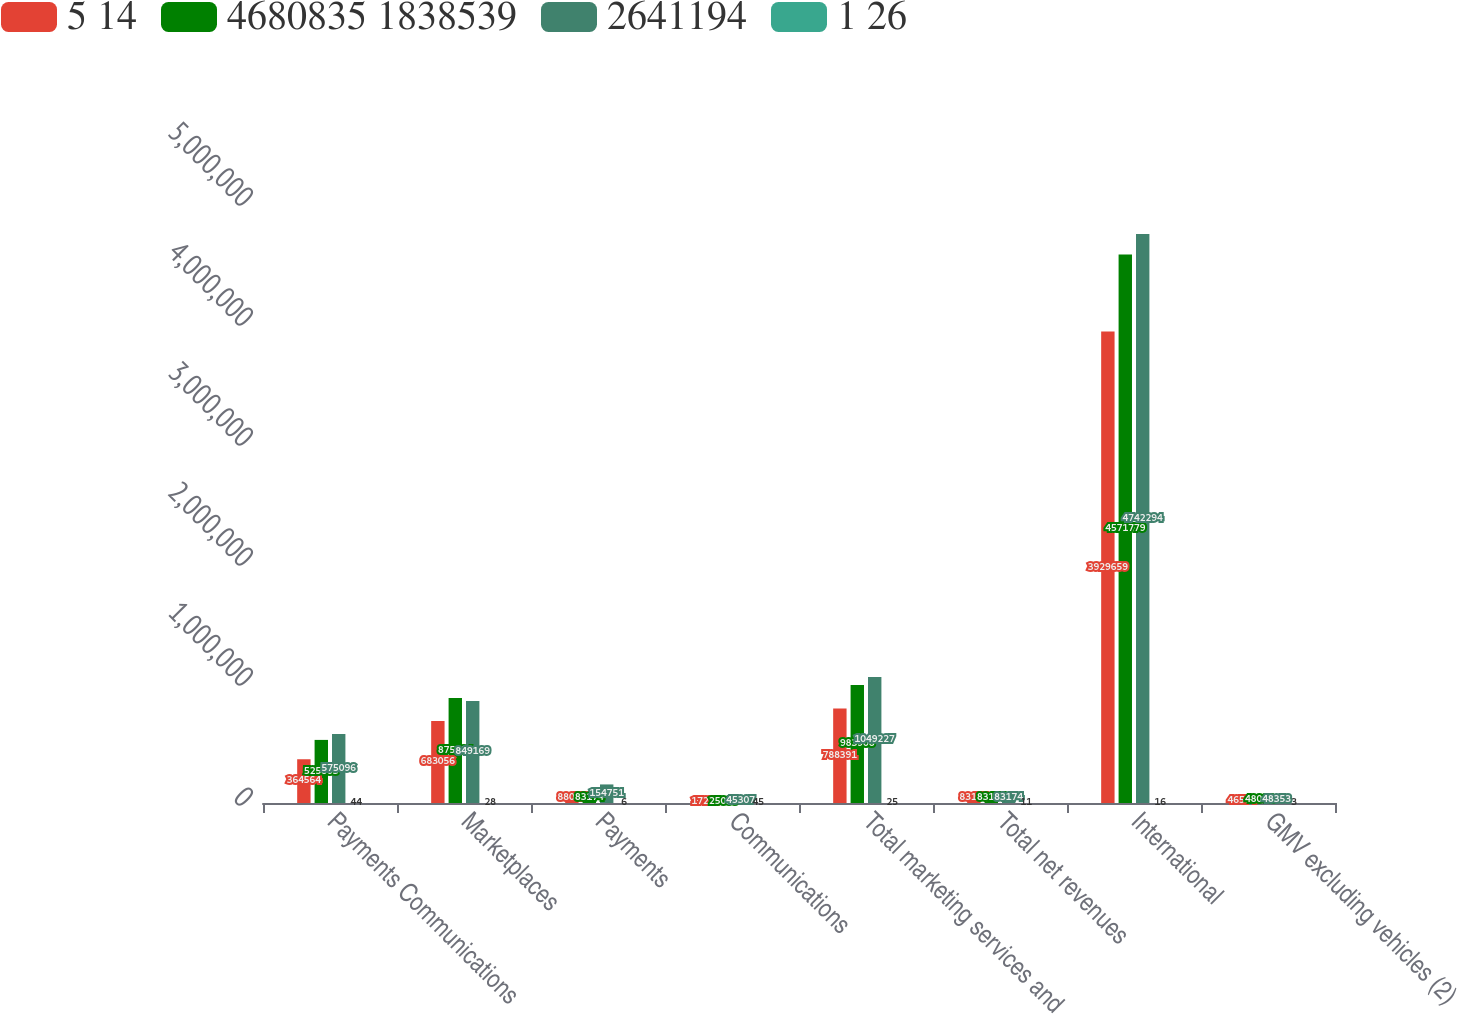Convert chart to OTSL. <chart><loc_0><loc_0><loc_500><loc_500><stacked_bar_chart><ecel><fcel>Payments Communications<fcel>Marketplaces<fcel>Payments<fcel>Communications<fcel>Total marketing services and<fcel>Total net revenues<fcel>International<fcel>GMV excluding vehicles (2)<nl><fcel>5 14<fcel>364564<fcel>683056<fcel>88077<fcel>17258<fcel>788391<fcel>83174<fcel>3.92966e+06<fcel>46574<nl><fcel>4680835 1838539<fcel>525803<fcel>875694<fcel>83174<fcel>25038<fcel>983906<fcel>83174<fcel>4.57178e+06<fcel>48001<nl><fcel>2641194<fcel>575096<fcel>849169<fcel>154751<fcel>45307<fcel>1.04923e+06<fcel>83174<fcel>4.74229e+06<fcel>48353<nl><fcel>1 26<fcel>44<fcel>28<fcel>6<fcel>45<fcel>25<fcel>11<fcel>16<fcel>3<nl></chart> 